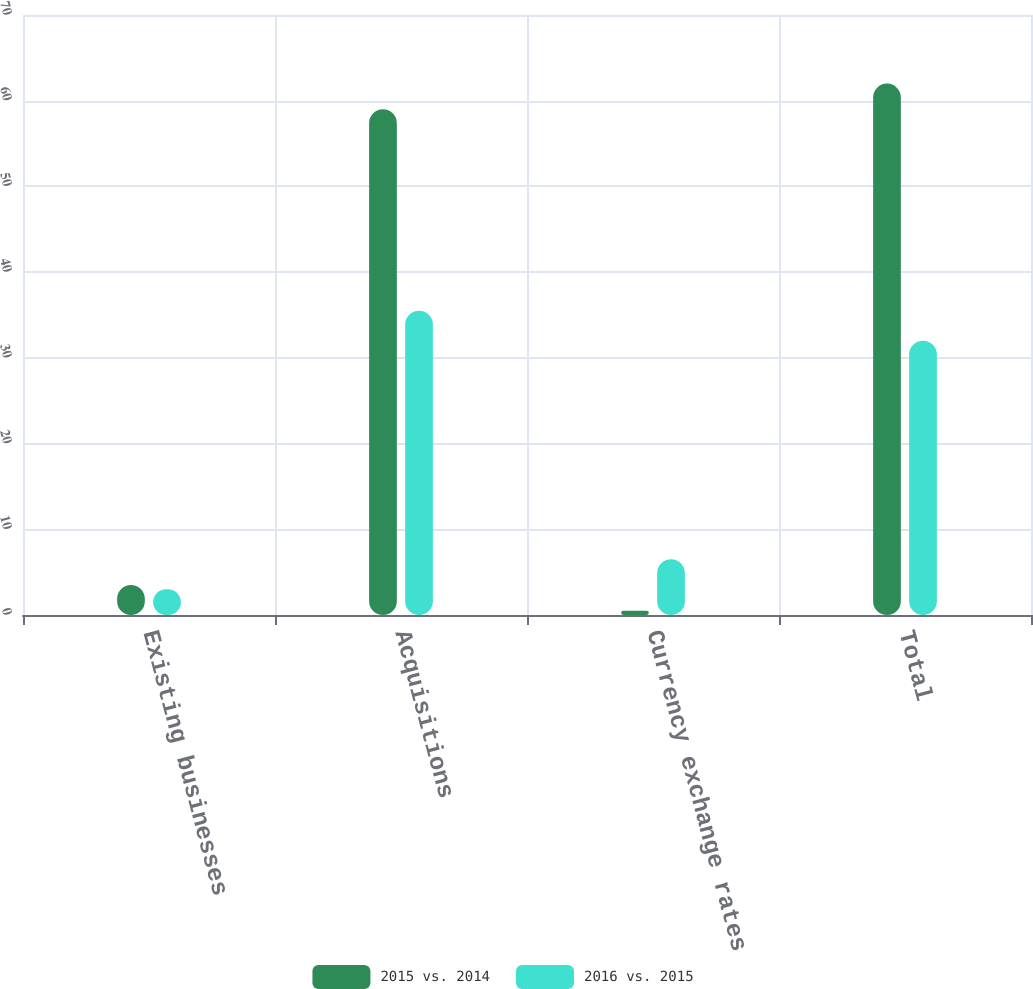Convert chart to OTSL. <chart><loc_0><loc_0><loc_500><loc_500><stacked_bar_chart><ecel><fcel>Existing businesses<fcel>Acquisitions<fcel>Currency exchange rates<fcel>Total<nl><fcel>2015 vs. 2014<fcel>3.5<fcel>59<fcel>0.5<fcel>62<nl><fcel>2016 vs. 2015<fcel>3<fcel>35.5<fcel>6.5<fcel>32<nl></chart> 